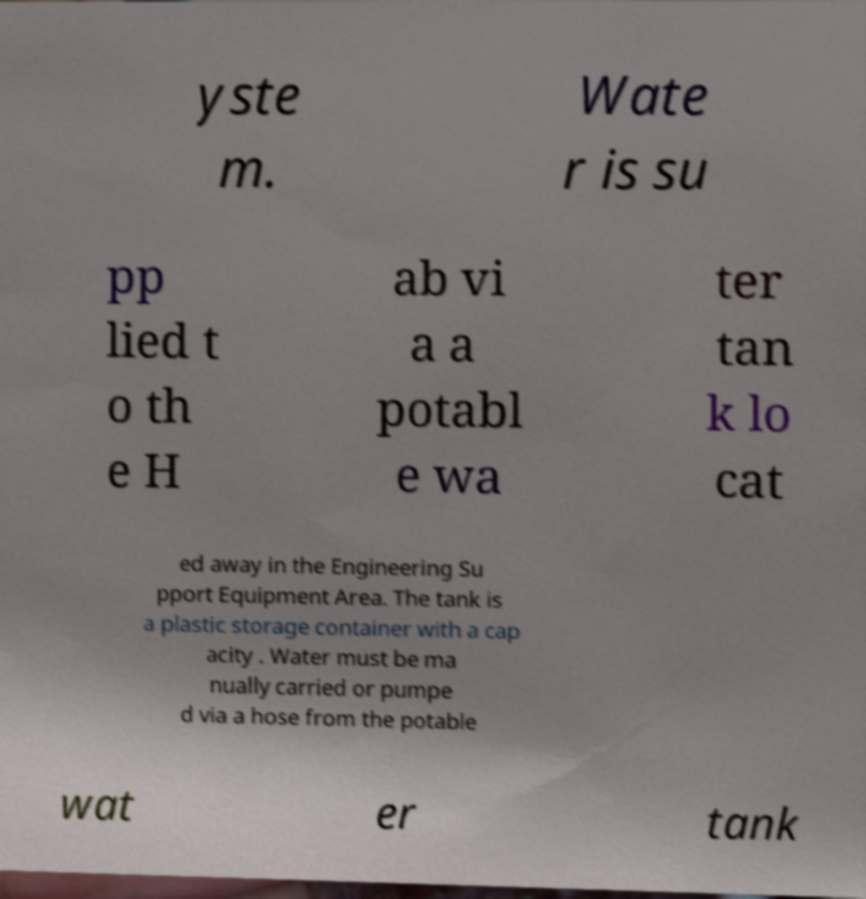Please read and relay the text visible in this image. What does it say? yste m. Wate r is su pp lied t o th e H ab vi a a potabl e wa ter tan k lo cat ed away in the Engineering Su pport Equipment Area. The tank is a plastic storage container with a cap acity . Water must be ma nually carried or pumpe d via a hose from the potable wat er tank 